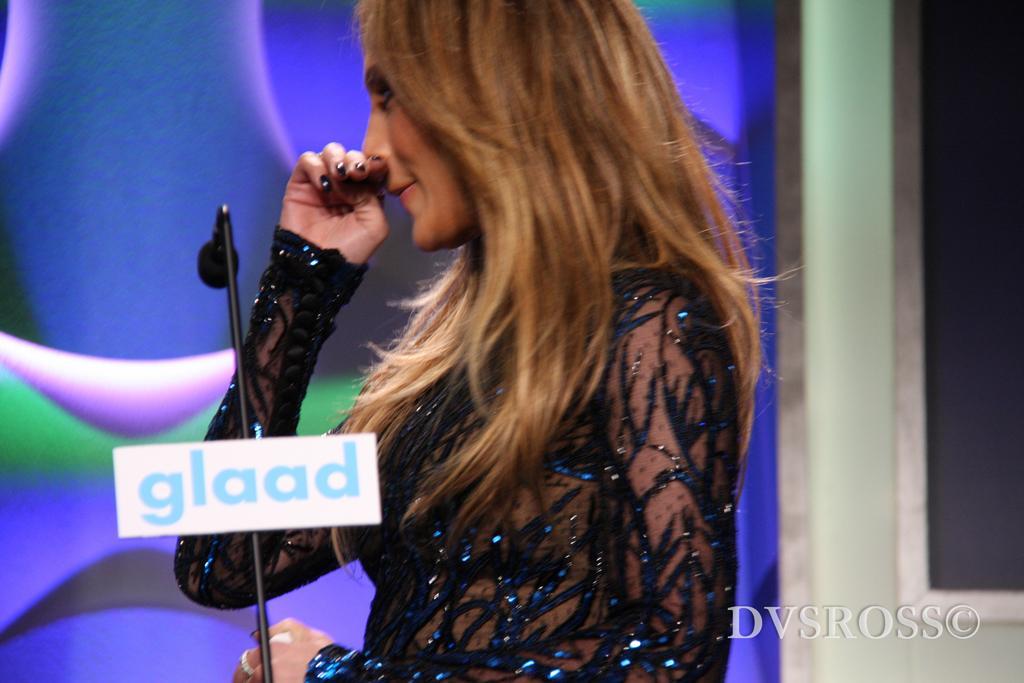How would you summarize this image in a sentence or two? In the picture we can see a woman standing in a side pose in a black dress and she's keeping her hand near her nose and in front of her we can see a microphone to the stand and behind her we can see the screen with blue color light designs on it. 